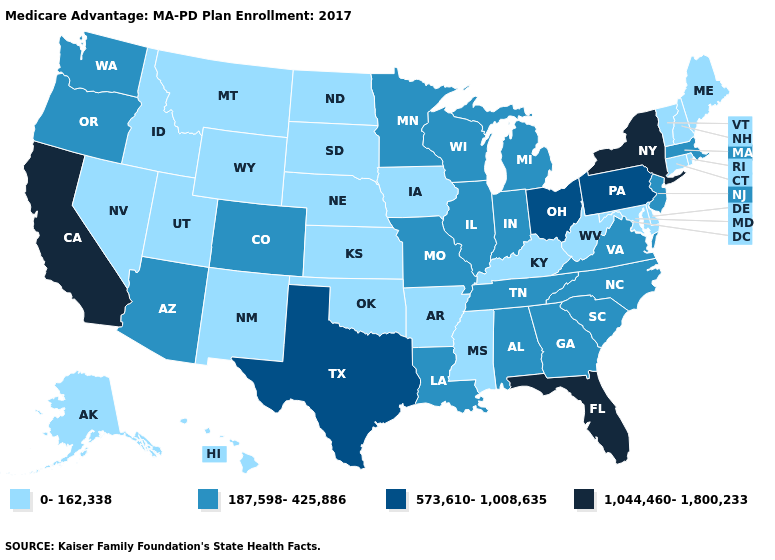Does the map have missing data?
Answer briefly. No. Name the states that have a value in the range 573,610-1,008,635?
Give a very brief answer. Ohio, Pennsylvania, Texas. Among the states that border South Dakota , which have the lowest value?
Give a very brief answer. Iowa, Montana, North Dakota, Nebraska, Wyoming. Which states hav the highest value in the MidWest?
Give a very brief answer. Ohio. Name the states that have a value in the range 0-162,338?
Concise answer only. Alaska, Arkansas, Connecticut, Delaware, Hawaii, Iowa, Idaho, Kansas, Kentucky, Maryland, Maine, Mississippi, Montana, North Dakota, Nebraska, New Hampshire, New Mexico, Nevada, Oklahoma, Rhode Island, South Dakota, Utah, Vermont, West Virginia, Wyoming. Among the states that border Washington , which have the lowest value?
Short answer required. Idaho. What is the value of Colorado?
Write a very short answer. 187,598-425,886. Does Massachusetts have a higher value than Tennessee?
Give a very brief answer. No. Does Nevada have the lowest value in the USA?
Answer briefly. Yes. Does the map have missing data?
Be succinct. No. Name the states that have a value in the range 573,610-1,008,635?
Short answer required. Ohio, Pennsylvania, Texas. What is the value of Delaware?
Concise answer only. 0-162,338. What is the value of Florida?
Short answer required. 1,044,460-1,800,233. What is the highest value in the Northeast ?
Be succinct. 1,044,460-1,800,233. What is the highest value in states that border Pennsylvania?
Be succinct. 1,044,460-1,800,233. 